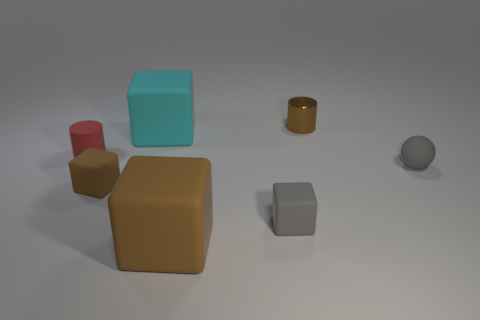Is there anything else that is made of the same material as the small brown cylinder?
Offer a very short reply. No. Is the number of matte spheres greater than the number of small blocks?
Keep it short and to the point. No. What number of gray matte things are the same size as the gray rubber sphere?
Your answer should be compact. 1. Do the small brown cube and the brown object in front of the gray block have the same material?
Keep it short and to the point. Yes. Is the number of big green metallic objects less than the number of rubber things?
Your response must be concise. Yes. Are there any other things that have the same color as the tiny metallic cylinder?
Provide a short and direct response. Yes. What shape is the large brown object that is made of the same material as the tiny red thing?
Your answer should be very brief. Cube. What number of tiny brown rubber blocks are behind the gray rubber object that is to the right of the tiny brown thing behind the small rubber cylinder?
Keep it short and to the point. 0. The thing that is in front of the brown cylinder and behind the small red object has what shape?
Keep it short and to the point. Cube. Are there fewer small rubber cylinders that are behind the big cyan rubber block than tiny yellow metallic blocks?
Keep it short and to the point. No. 